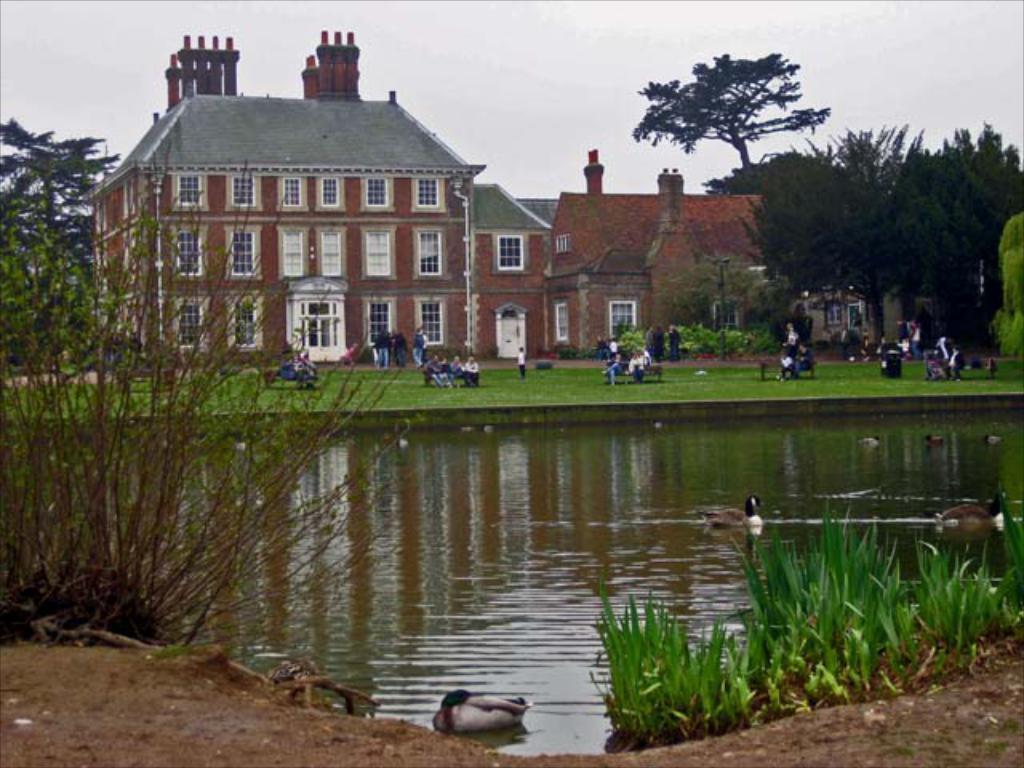Can you describe this image briefly? In the foreground of the picture we can see pond, ducks, grass, plant and soil. In the middle of the picture there are trees, buildings, people, benches and various objects. At the top there is sky. 